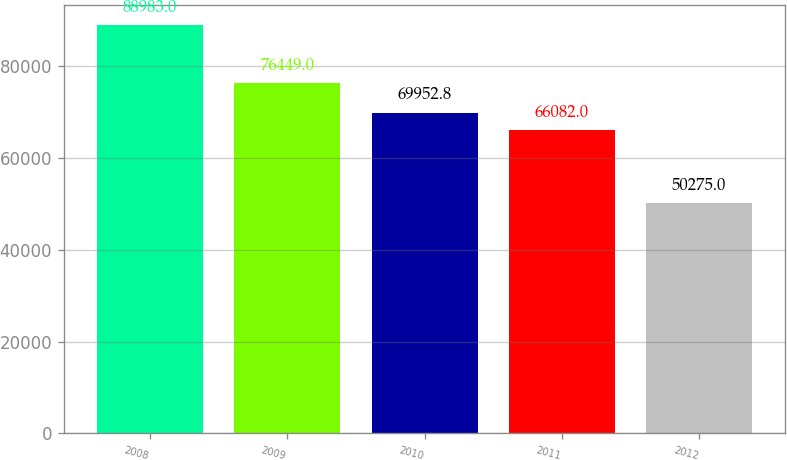<chart> <loc_0><loc_0><loc_500><loc_500><bar_chart><fcel>2008<fcel>2009<fcel>2010<fcel>2011<fcel>2012<nl><fcel>88983<fcel>76449<fcel>69952.8<fcel>66082<fcel>50275<nl></chart> 